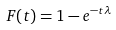Convert formula to latex. <formula><loc_0><loc_0><loc_500><loc_500>F ( t ) = 1 - e ^ { { - t } { \lambda } }</formula> 